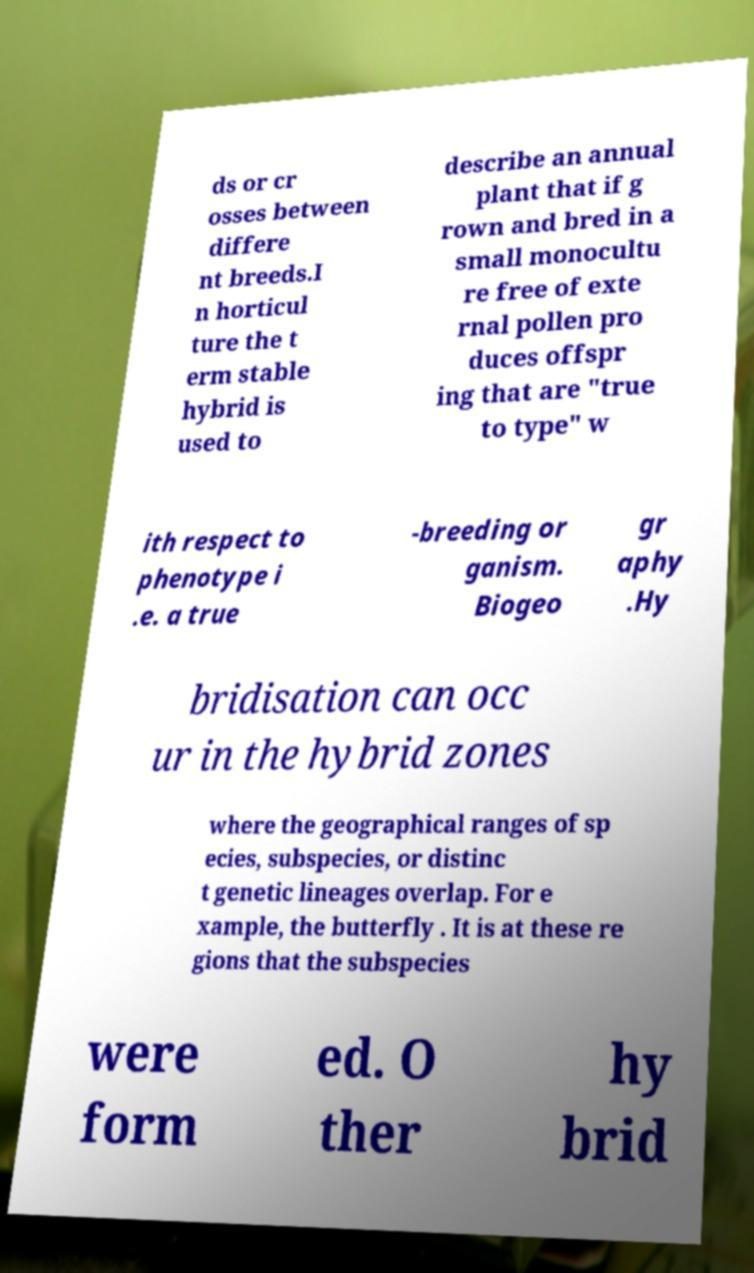Can you read and provide the text displayed in the image?This photo seems to have some interesting text. Can you extract and type it out for me? ds or cr osses between differe nt breeds.I n horticul ture the t erm stable hybrid is used to describe an annual plant that if g rown and bred in a small monocultu re free of exte rnal pollen pro duces offspr ing that are "true to type" w ith respect to phenotype i .e. a true -breeding or ganism. Biogeo gr aphy .Hy bridisation can occ ur in the hybrid zones where the geographical ranges of sp ecies, subspecies, or distinc t genetic lineages overlap. For e xample, the butterfly . It is at these re gions that the subspecies were form ed. O ther hy brid 